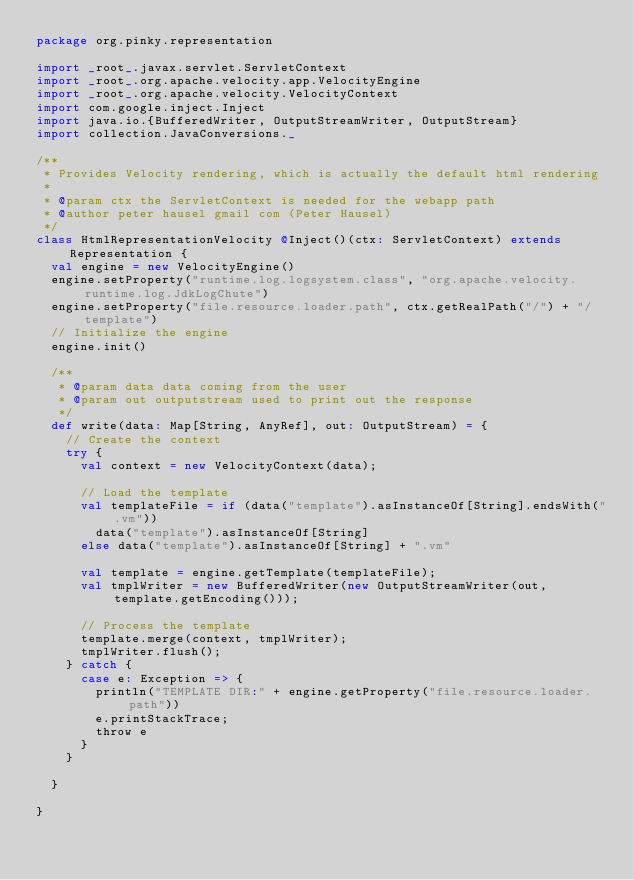Convert code to text. <code><loc_0><loc_0><loc_500><loc_500><_Scala_>package org.pinky.representation

import _root_.javax.servlet.ServletContext
import _root_.org.apache.velocity.app.VelocityEngine
import _root_.org.apache.velocity.VelocityContext
import com.google.inject.Inject
import java.io.{BufferedWriter, OutputStreamWriter, OutputStream}
import collection.JavaConversions._

/**
 * Provides Velocity rendering, which is actually the default html rendering
 *
 * @param ctx the ServletContext is needed for the webapp path
 * @author peter hausel gmail com (Peter Hausel)
 */
class HtmlRepresentationVelocity @Inject()(ctx: ServletContext) extends Representation {
  val engine = new VelocityEngine()
  engine.setProperty("runtime.log.logsystem.class", "org.apache.velocity.runtime.log.JdkLogChute")
  engine.setProperty("file.resource.loader.path", ctx.getRealPath("/") + "/template")
  // Initialize the engine
  engine.init()

  /**
   * @param data data coming from the user
   * @param out outputstream used to print out the response
   */
  def write(data: Map[String, AnyRef], out: OutputStream) = {
    // Create the context
    try {
      val context = new VelocityContext(data);

      // Load the template
      val templateFile = if (data("template").asInstanceOf[String].endsWith(".vm"))
        data("template").asInstanceOf[String]
      else data("template").asInstanceOf[String] + ".vm"

      val template = engine.getTemplate(templateFile);
      val tmplWriter = new BufferedWriter(new OutputStreamWriter(out, template.getEncoding()));

      // Process the template
      template.merge(context, tmplWriter);
      tmplWriter.flush();
    } catch {
      case e: Exception => {
        println("TEMPLATE DIR:" + engine.getProperty("file.resource.loader.path"))
        e.printStackTrace;
        throw e
      }
    }

  }

}
</code> 